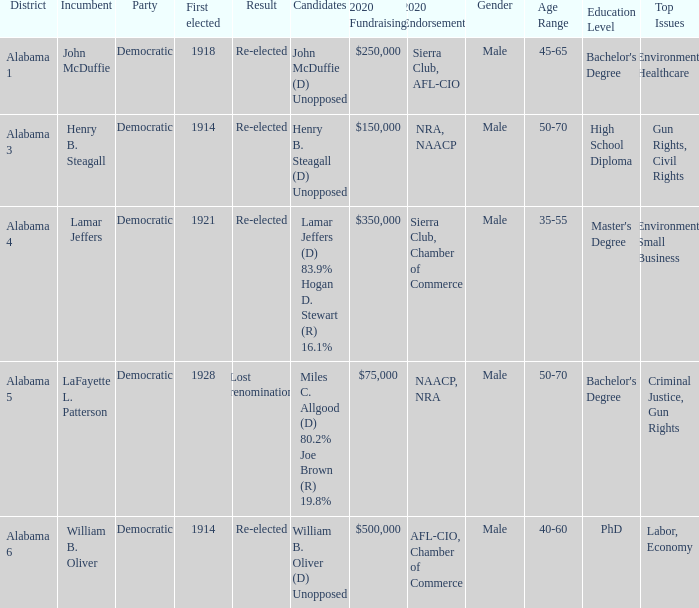How many in total were elected first in lost renomination? 1.0. 